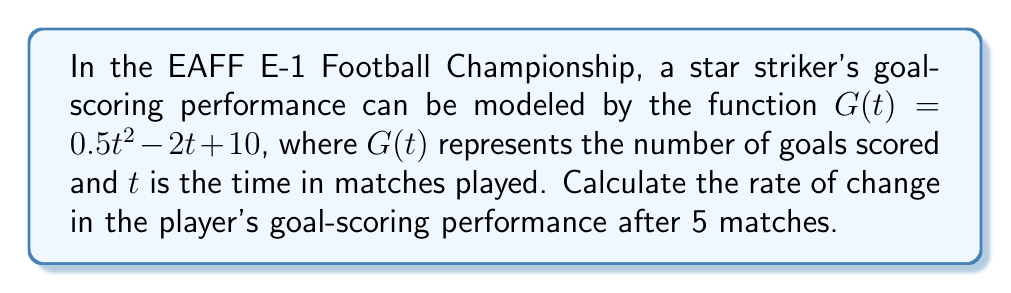Solve this math problem. To find the rate of change in the player's goal-scoring performance, we need to calculate the derivative of the given function $G(t)$ and then evaluate it at $t = 5$.

Step 1: Find the derivative of $G(t)$.
$$G(t) = 0.5t^2 - 2t + 10$$
$$G'(t) = \frac{d}{dt}(0.5t^2 - 2t + 10)$$
$$G'(t) = 0.5 \cdot 2t - 2 + 0$$
$$G'(t) = t - 2$$

Step 2: Evaluate the derivative at $t = 5$.
$$G'(5) = 5 - 2 = 3$$

The rate of change in the player's goal-scoring performance after 5 matches is 3 goals per match.
Answer: $3$ goals per match 